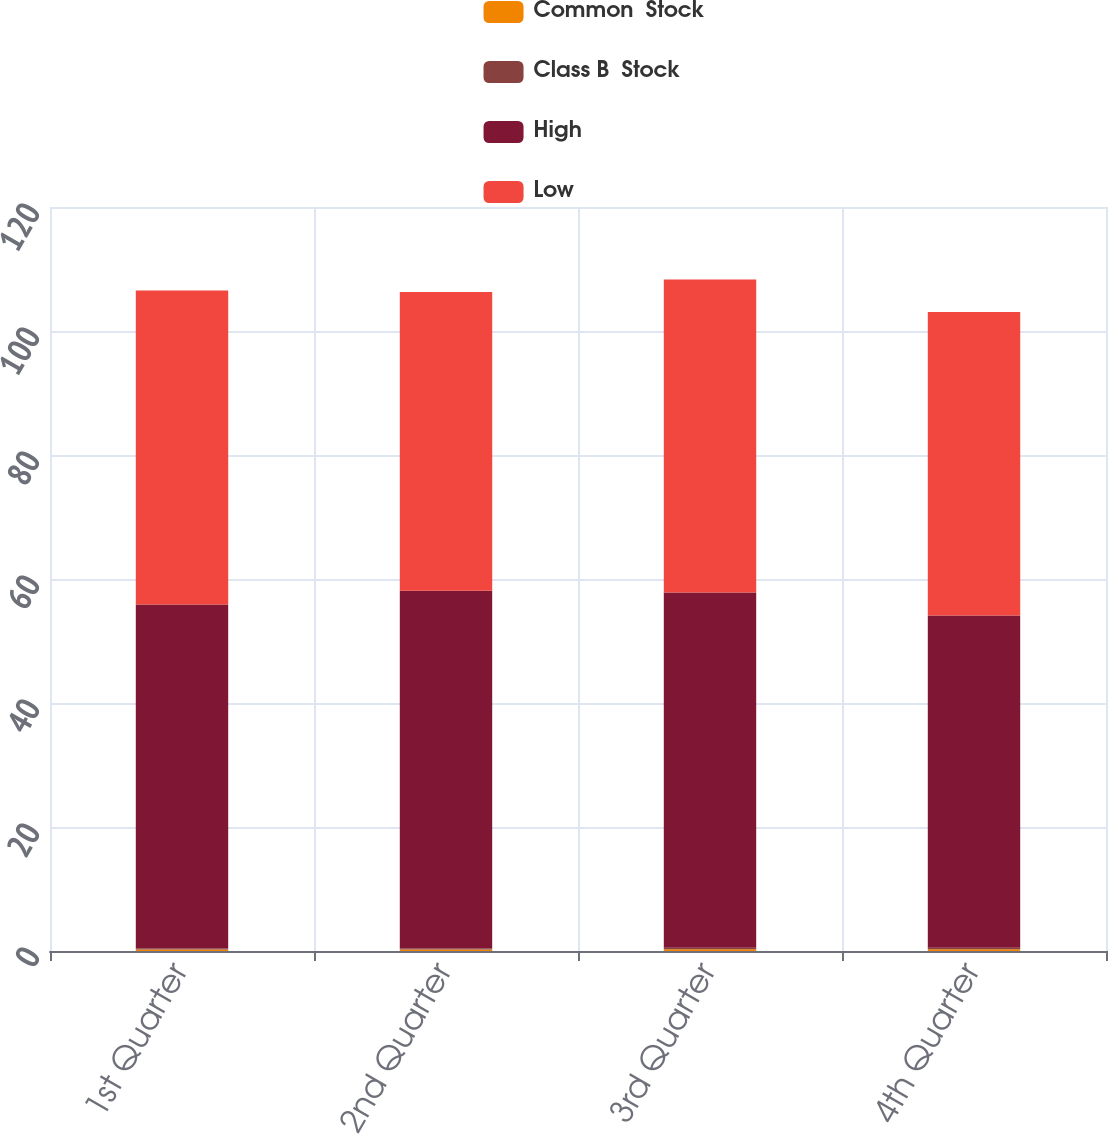<chart> <loc_0><loc_0><loc_500><loc_500><stacked_bar_chart><ecel><fcel>1st Quarter<fcel>2nd Quarter<fcel>3rd Quarter<fcel>4th Quarter<nl><fcel>Common  Stock<fcel>0.24<fcel>0.24<fcel>0.27<fcel>0.27<nl><fcel>Class B  Stock<fcel>0.22<fcel>0.22<fcel>0.24<fcel>0.24<nl><fcel>High<fcel>55.44<fcel>57.65<fcel>57.3<fcel>53.6<nl><fcel>Low<fcel>50.62<fcel>48.2<fcel>50.48<fcel>48.96<nl></chart> 